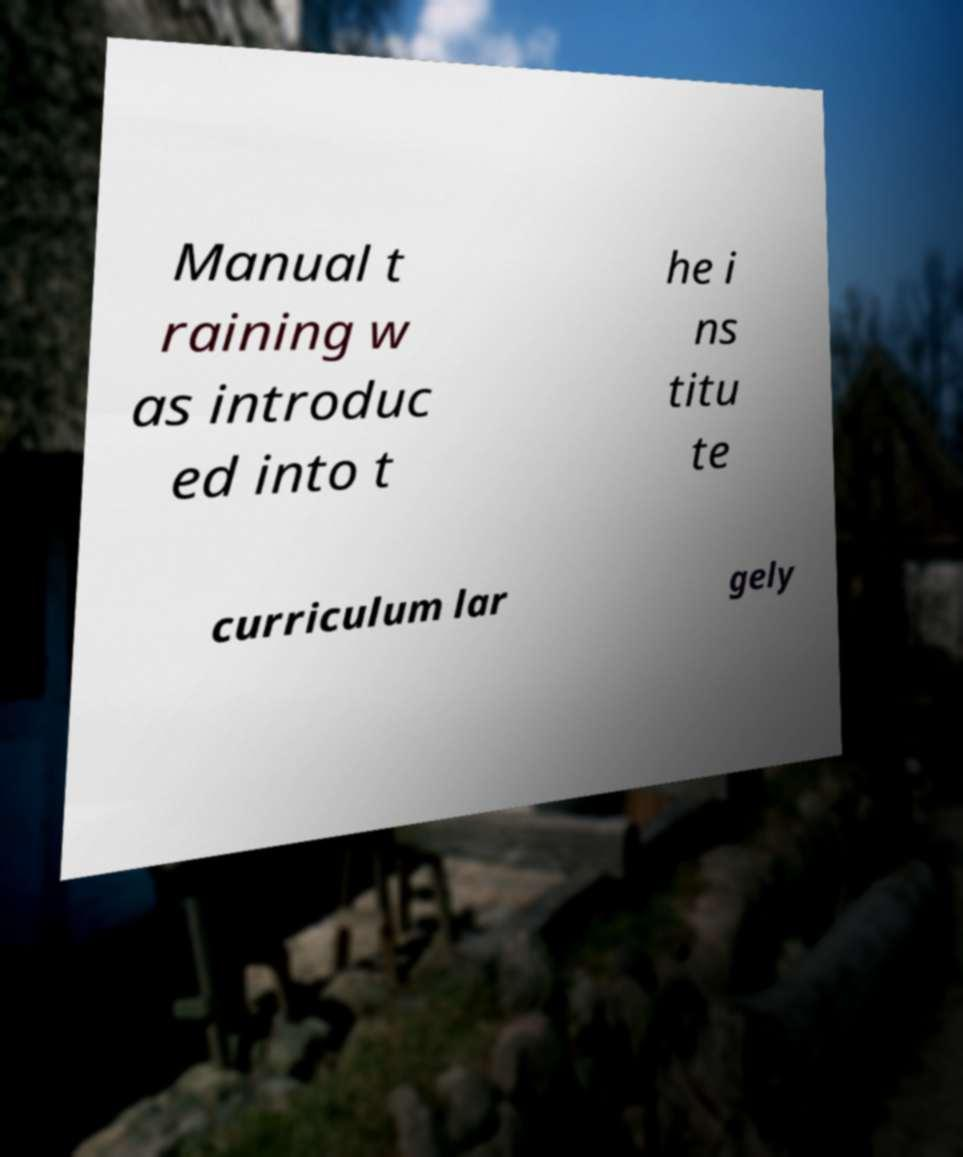There's text embedded in this image that I need extracted. Can you transcribe it verbatim? Manual t raining w as introduc ed into t he i ns titu te curriculum lar gely 